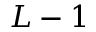Convert formula to latex. <formula><loc_0><loc_0><loc_500><loc_500>L - 1</formula> 